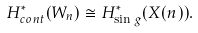Convert formula to latex. <formula><loc_0><loc_0><loc_500><loc_500>H ^ { * } _ { c o n t } ( W _ { n } ) \cong H ^ { * } _ { \sin g } ( X ( n ) ) .</formula> 